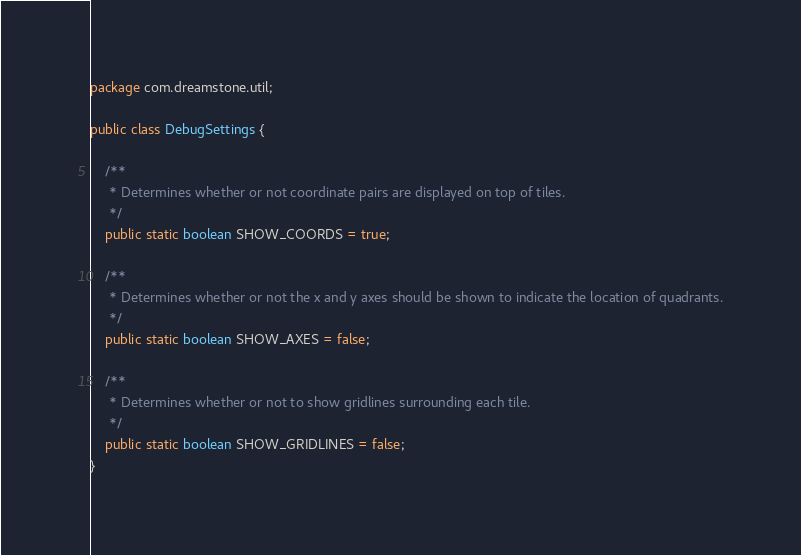<code> <loc_0><loc_0><loc_500><loc_500><_Java_>package com.dreamstone.util;

public class DebugSettings {
	
	/**
	 * Determines whether or not coordinate pairs are displayed on top of tiles.
	 */
	public static boolean SHOW_COORDS = true;
	
	/**
	 * Determines whether or not the x and y axes should be shown to indicate the location of quadrants.
	 */
	public static boolean SHOW_AXES = false;
	
	/**
	 * Determines whether or not to show gridlines surrounding each tile.
	 */
	public static boolean SHOW_GRIDLINES = false;
}
</code> 